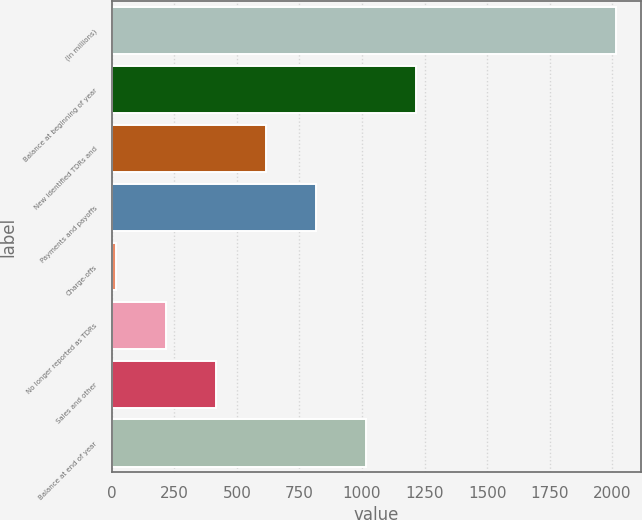Convert chart to OTSL. <chart><loc_0><loc_0><loc_500><loc_500><bar_chart><fcel>(In millions)<fcel>Balance at beginning of year<fcel>New identified TDRs and<fcel>Payments and payoffs<fcel>Charge-offs<fcel>No longer reported as TDRs<fcel>Sales and other<fcel>Balance at end of year<nl><fcel>2013<fcel>1215<fcel>616.5<fcel>816<fcel>18<fcel>217.5<fcel>417<fcel>1015.5<nl></chart> 